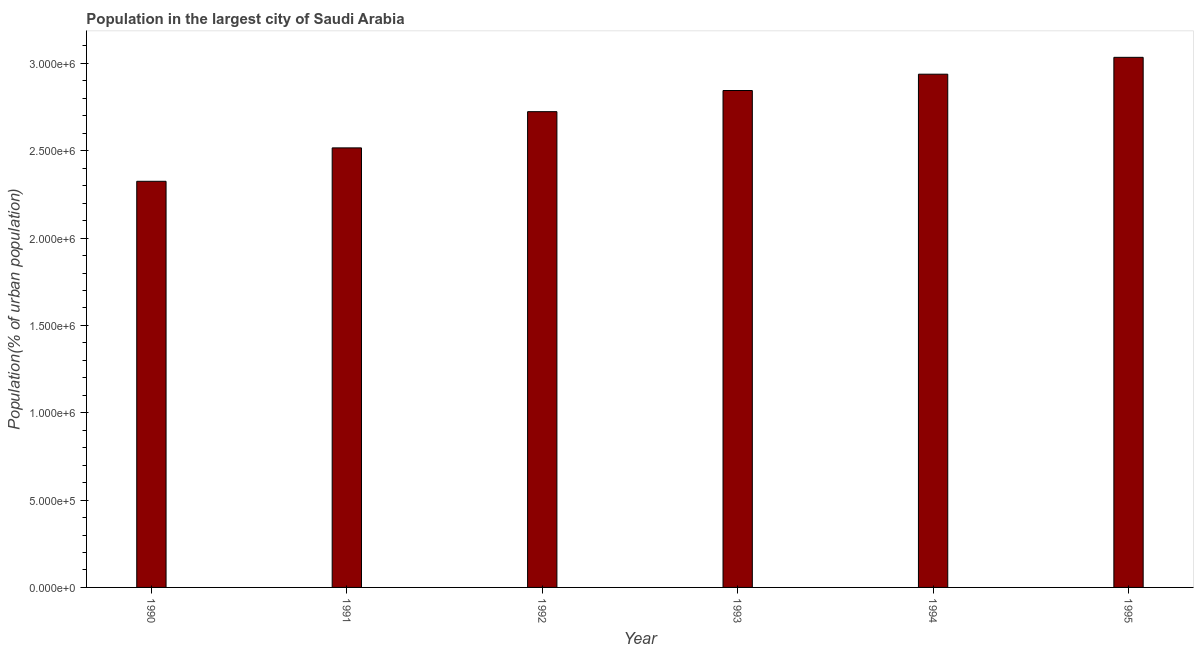Does the graph contain any zero values?
Provide a short and direct response. No. What is the title of the graph?
Make the answer very short. Population in the largest city of Saudi Arabia. What is the label or title of the X-axis?
Ensure brevity in your answer.  Year. What is the label or title of the Y-axis?
Offer a very short reply. Population(% of urban population). What is the population in largest city in 1991?
Provide a short and direct response. 2.52e+06. Across all years, what is the maximum population in largest city?
Give a very brief answer. 3.03e+06. Across all years, what is the minimum population in largest city?
Keep it short and to the point. 2.33e+06. What is the sum of the population in largest city?
Keep it short and to the point. 1.64e+07. What is the difference between the population in largest city in 1990 and 1992?
Offer a terse response. -3.99e+05. What is the average population in largest city per year?
Give a very brief answer. 2.73e+06. What is the median population in largest city?
Give a very brief answer. 2.78e+06. In how many years, is the population in largest city greater than 100000 %?
Your answer should be compact. 6. What is the ratio of the population in largest city in 1993 to that in 1995?
Provide a succinct answer. 0.94. Is the difference between the population in largest city in 1990 and 1993 greater than the difference between any two years?
Offer a very short reply. No. What is the difference between the highest and the second highest population in largest city?
Your answer should be compact. 9.65e+04. What is the difference between the highest and the lowest population in largest city?
Give a very brief answer. 7.10e+05. In how many years, is the population in largest city greater than the average population in largest city taken over all years?
Give a very brief answer. 3. Are all the bars in the graph horizontal?
Give a very brief answer. No. How many years are there in the graph?
Give a very brief answer. 6. What is the difference between two consecutive major ticks on the Y-axis?
Offer a very short reply. 5.00e+05. Are the values on the major ticks of Y-axis written in scientific E-notation?
Offer a terse response. Yes. What is the Population(% of urban population) in 1990?
Your response must be concise. 2.33e+06. What is the Population(% of urban population) of 1991?
Offer a terse response. 2.52e+06. What is the Population(% of urban population) of 1992?
Make the answer very short. 2.72e+06. What is the Population(% of urban population) of 1993?
Keep it short and to the point. 2.84e+06. What is the Population(% of urban population) in 1994?
Keep it short and to the point. 2.94e+06. What is the Population(% of urban population) in 1995?
Offer a terse response. 3.03e+06. What is the difference between the Population(% of urban population) in 1990 and 1991?
Keep it short and to the point. -1.91e+05. What is the difference between the Population(% of urban population) in 1990 and 1992?
Offer a very short reply. -3.99e+05. What is the difference between the Population(% of urban population) in 1990 and 1993?
Offer a very short reply. -5.20e+05. What is the difference between the Population(% of urban population) in 1990 and 1994?
Ensure brevity in your answer.  -6.13e+05. What is the difference between the Population(% of urban population) in 1990 and 1995?
Your answer should be very brief. -7.10e+05. What is the difference between the Population(% of urban population) in 1991 and 1992?
Your response must be concise. -2.07e+05. What is the difference between the Population(% of urban population) in 1991 and 1993?
Your response must be concise. -3.28e+05. What is the difference between the Population(% of urban population) in 1991 and 1994?
Your answer should be very brief. -4.22e+05. What is the difference between the Population(% of urban population) in 1991 and 1995?
Your answer should be compact. -5.18e+05. What is the difference between the Population(% of urban population) in 1992 and 1993?
Make the answer very short. -1.21e+05. What is the difference between the Population(% of urban population) in 1992 and 1994?
Offer a terse response. -2.15e+05. What is the difference between the Population(% of urban population) in 1992 and 1995?
Your response must be concise. -3.11e+05. What is the difference between the Population(% of urban population) in 1993 and 1994?
Your response must be concise. -9.35e+04. What is the difference between the Population(% of urban population) in 1993 and 1995?
Offer a terse response. -1.90e+05. What is the difference between the Population(% of urban population) in 1994 and 1995?
Keep it short and to the point. -9.65e+04. What is the ratio of the Population(% of urban population) in 1990 to that in 1991?
Your answer should be very brief. 0.92. What is the ratio of the Population(% of urban population) in 1990 to that in 1992?
Give a very brief answer. 0.85. What is the ratio of the Population(% of urban population) in 1990 to that in 1993?
Your answer should be very brief. 0.82. What is the ratio of the Population(% of urban population) in 1990 to that in 1994?
Offer a terse response. 0.79. What is the ratio of the Population(% of urban population) in 1990 to that in 1995?
Keep it short and to the point. 0.77. What is the ratio of the Population(% of urban population) in 1991 to that in 1992?
Your response must be concise. 0.92. What is the ratio of the Population(% of urban population) in 1991 to that in 1993?
Ensure brevity in your answer.  0.89. What is the ratio of the Population(% of urban population) in 1991 to that in 1994?
Ensure brevity in your answer.  0.86. What is the ratio of the Population(% of urban population) in 1991 to that in 1995?
Provide a succinct answer. 0.83. What is the ratio of the Population(% of urban population) in 1992 to that in 1993?
Provide a short and direct response. 0.96. What is the ratio of the Population(% of urban population) in 1992 to that in 1994?
Provide a succinct answer. 0.93. What is the ratio of the Population(% of urban population) in 1992 to that in 1995?
Offer a terse response. 0.9. What is the ratio of the Population(% of urban population) in 1993 to that in 1994?
Ensure brevity in your answer.  0.97. What is the ratio of the Population(% of urban population) in 1993 to that in 1995?
Ensure brevity in your answer.  0.94. What is the ratio of the Population(% of urban population) in 1994 to that in 1995?
Provide a short and direct response. 0.97. 